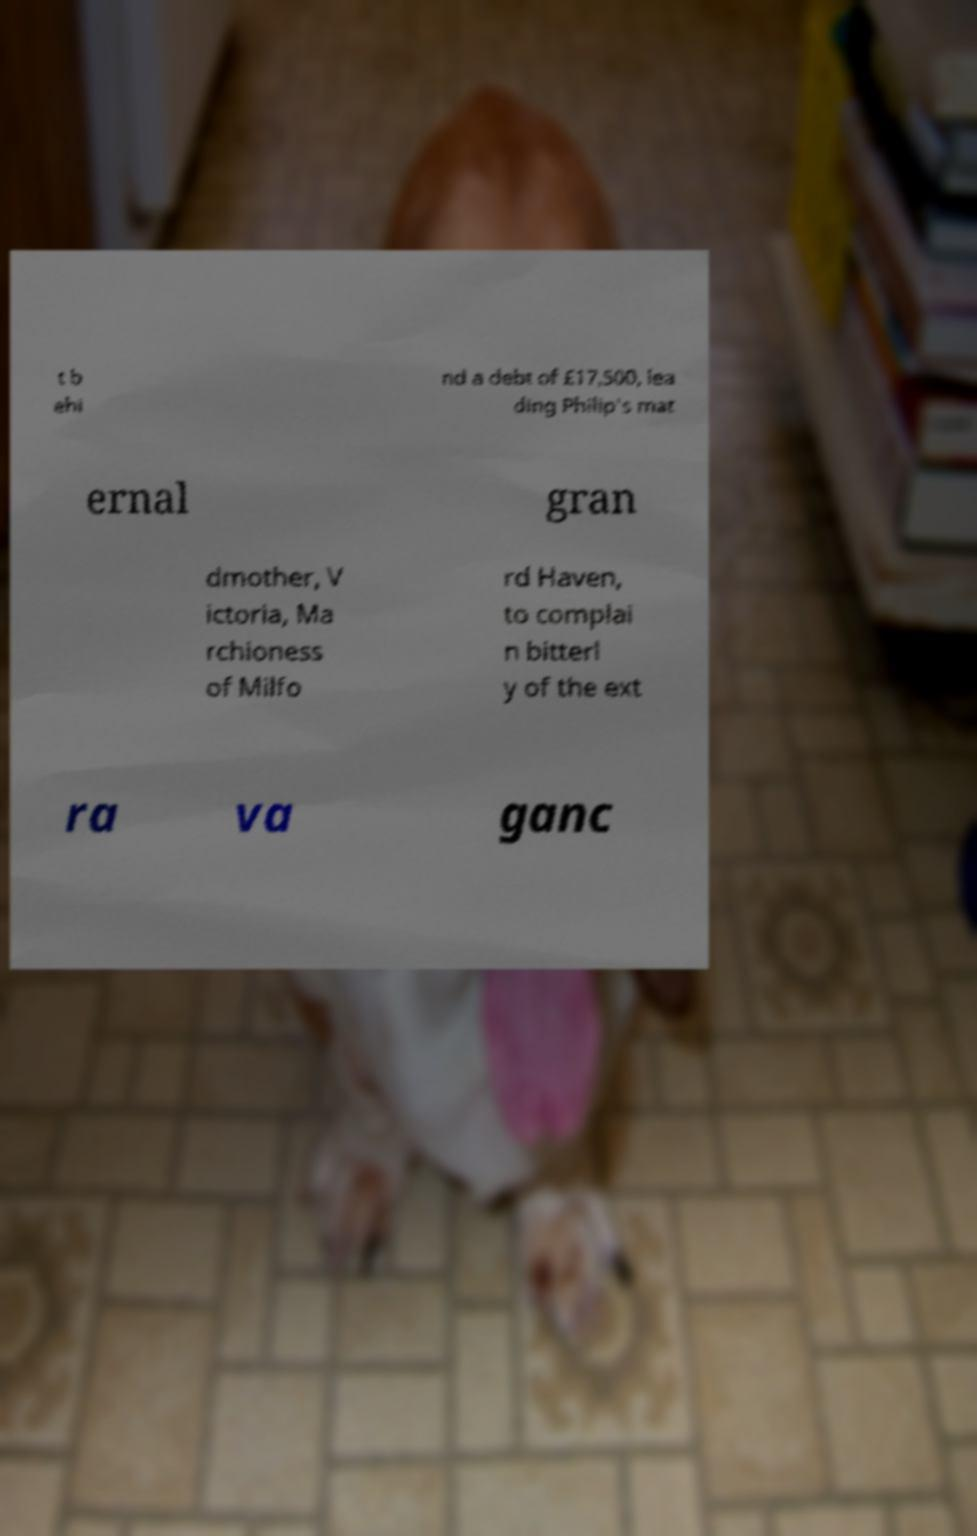Can you read and provide the text displayed in the image?This photo seems to have some interesting text. Can you extract and type it out for me? t b ehi nd a debt of £17,500, lea ding Philip's mat ernal gran dmother, V ictoria, Ma rchioness of Milfo rd Haven, to complai n bitterl y of the ext ra va ganc 